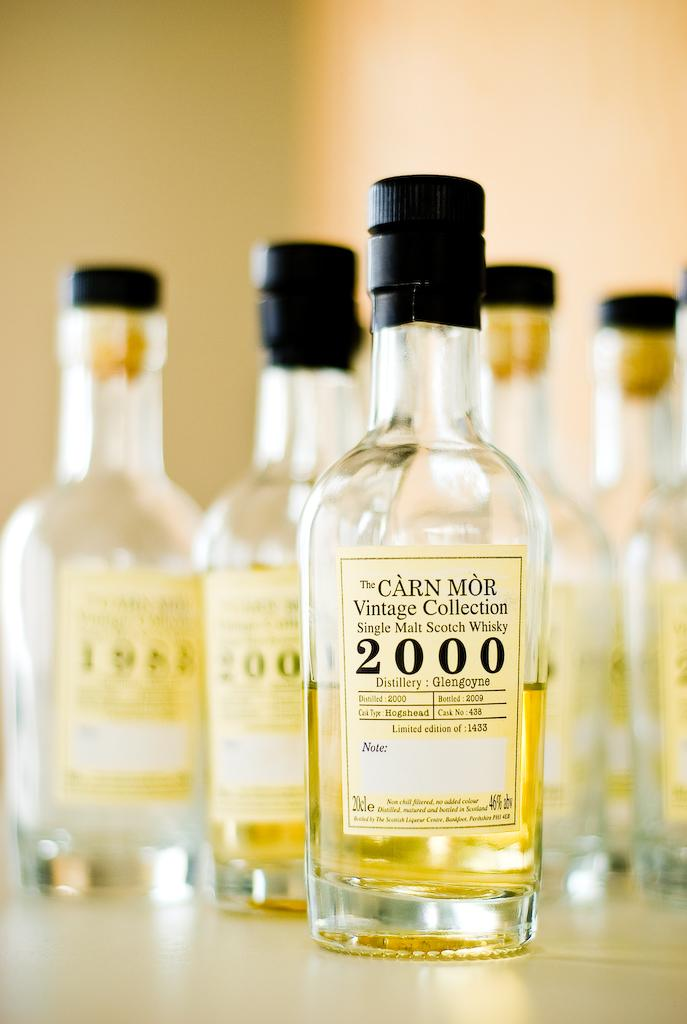<image>
Render a clear and concise summary of the photo. A row of Carn Mor Vintage Collection singe malt scotch whisky bottles. 